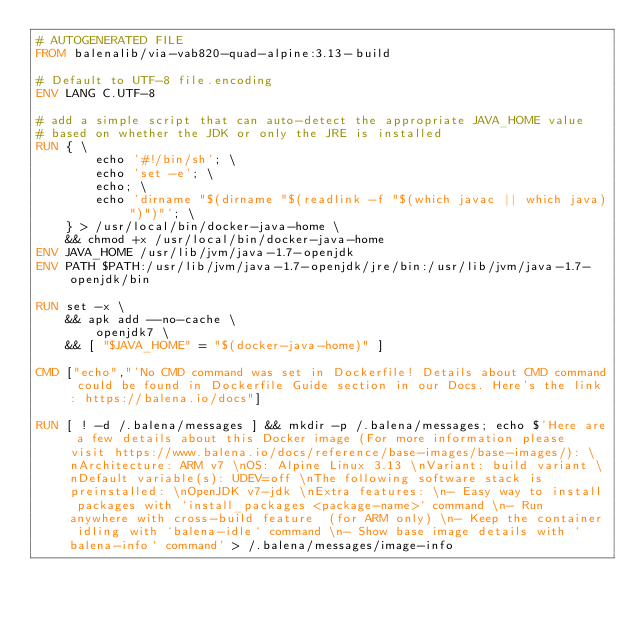Convert code to text. <code><loc_0><loc_0><loc_500><loc_500><_Dockerfile_># AUTOGENERATED FILE
FROM balenalib/via-vab820-quad-alpine:3.13-build

# Default to UTF-8 file.encoding
ENV LANG C.UTF-8

# add a simple script that can auto-detect the appropriate JAVA_HOME value
# based on whether the JDK or only the JRE is installed
RUN { \
		echo '#!/bin/sh'; \
		echo 'set -e'; \
		echo; \
		echo 'dirname "$(dirname "$(readlink -f "$(which javac || which java)")")"'; \
	} > /usr/local/bin/docker-java-home \
	&& chmod +x /usr/local/bin/docker-java-home
ENV JAVA_HOME /usr/lib/jvm/java-1.7-openjdk
ENV PATH $PATH:/usr/lib/jvm/java-1.7-openjdk/jre/bin:/usr/lib/jvm/java-1.7-openjdk/bin

RUN set -x \
	&& apk add --no-cache \
		openjdk7 \
	&& [ "$JAVA_HOME" = "$(docker-java-home)" ]

CMD ["echo","'No CMD command was set in Dockerfile! Details about CMD command could be found in Dockerfile Guide section in our Docs. Here's the link: https://balena.io/docs"]

RUN [ ! -d /.balena/messages ] && mkdir -p /.balena/messages; echo $'Here are a few details about this Docker image (For more information please visit https://www.balena.io/docs/reference/base-images/base-images/): \nArchitecture: ARM v7 \nOS: Alpine Linux 3.13 \nVariant: build variant \nDefault variable(s): UDEV=off \nThe following software stack is preinstalled: \nOpenJDK v7-jdk \nExtra features: \n- Easy way to install packages with `install_packages <package-name>` command \n- Run anywhere with cross-build feature  (for ARM only) \n- Keep the container idling with `balena-idle` command \n- Show base image details with `balena-info` command' > /.balena/messages/image-info</code> 